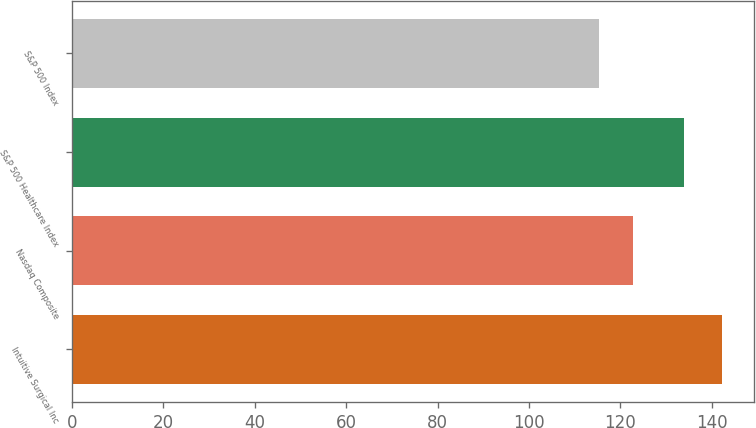Convert chart to OTSL. <chart><loc_0><loc_0><loc_500><loc_500><bar_chart><fcel>Intuitive Surgical Inc<fcel>Nasdaq Composite<fcel>S&P 500 Healthcare Index<fcel>S&P 500 Index<nl><fcel>142.2<fcel>122.74<fcel>133.97<fcel>115.26<nl></chart> 